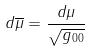Convert formula to latex. <formula><loc_0><loc_0><loc_500><loc_500>d \overline { \mu } = \frac { d \mu } { \sqrt { g _ { 0 0 } } }</formula> 